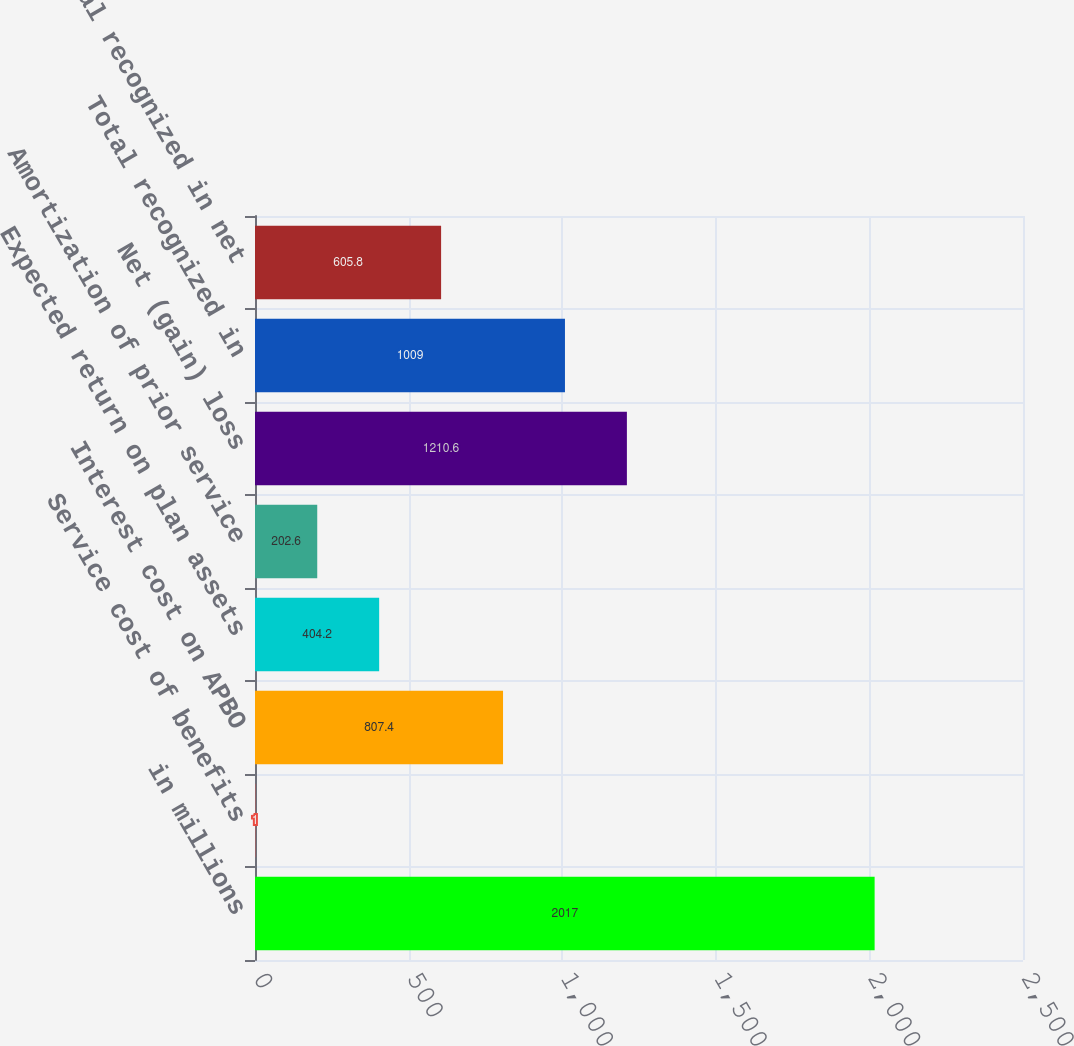Convert chart. <chart><loc_0><loc_0><loc_500><loc_500><bar_chart><fcel>in millions<fcel>Service cost of benefits<fcel>Interest cost on APBO<fcel>Expected return on plan assets<fcel>Amortization of prior service<fcel>Net (gain) loss<fcel>Total recognized in<fcel>Total recognized in net<nl><fcel>2017<fcel>1<fcel>807.4<fcel>404.2<fcel>202.6<fcel>1210.6<fcel>1009<fcel>605.8<nl></chart> 